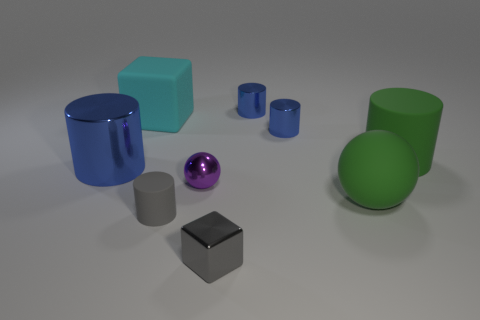Subtract all big metallic cylinders. How many cylinders are left? 4 Subtract 1 spheres. How many spheres are left? 1 Subtract all green cylinders. How many cylinders are left? 4 Subtract all balls. How many objects are left? 7 Add 6 small metal cubes. How many small metal cubes exist? 7 Subtract 1 green spheres. How many objects are left? 8 Subtract all green cylinders. Subtract all red spheres. How many cylinders are left? 4 Subtract all cyan spheres. How many green cylinders are left? 1 Subtract all big matte balls. Subtract all big cyan matte cubes. How many objects are left? 7 Add 5 tiny blue things. How many tiny blue things are left? 7 